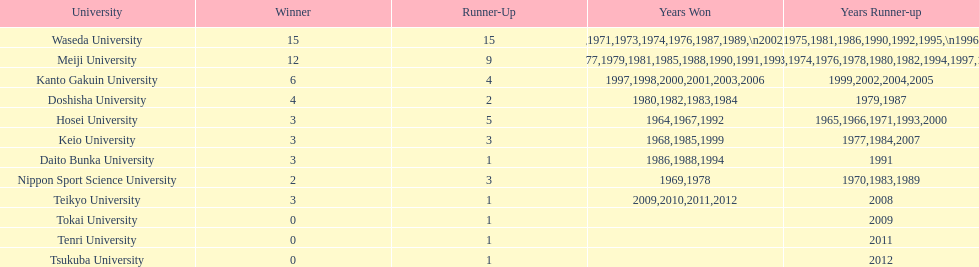Which university had the most years won? Waseda University. 